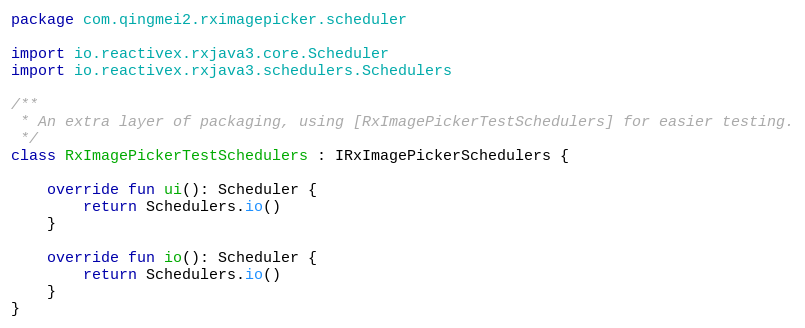Convert code to text. <code><loc_0><loc_0><loc_500><loc_500><_Kotlin_>package com.qingmei2.rximagepicker.scheduler

import io.reactivex.rxjava3.core.Scheduler
import io.reactivex.rxjava3.schedulers.Schedulers

/**
 * An extra layer of packaging, using [RxImagePickerTestSchedulers] for easier testing.
 */
class RxImagePickerTestSchedulers : IRxImagePickerSchedulers {

    override fun ui(): Scheduler {
        return Schedulers.io()
    }

    override fun io(): Scheduler {
        return Schedulers.io()
    }
}
</code> 